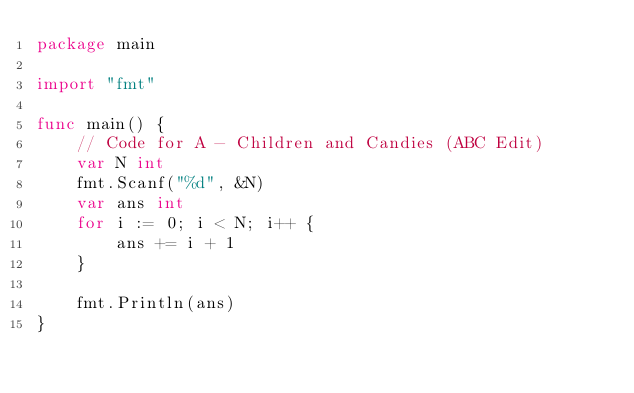Convert code to text. <code><loc_0><loc_0><loc_500><loc_500><_Go_>package main

import "fmt"

func main() {
	// Code for A - Children and Candies (ABC Edit)
	var N int
	fmt.Scanf("%d", &N)
	var ans int
	for i := 0; i < N; i++ {
		ans += i + 1
	}

	fmt.Println(ans)
}
</code> 